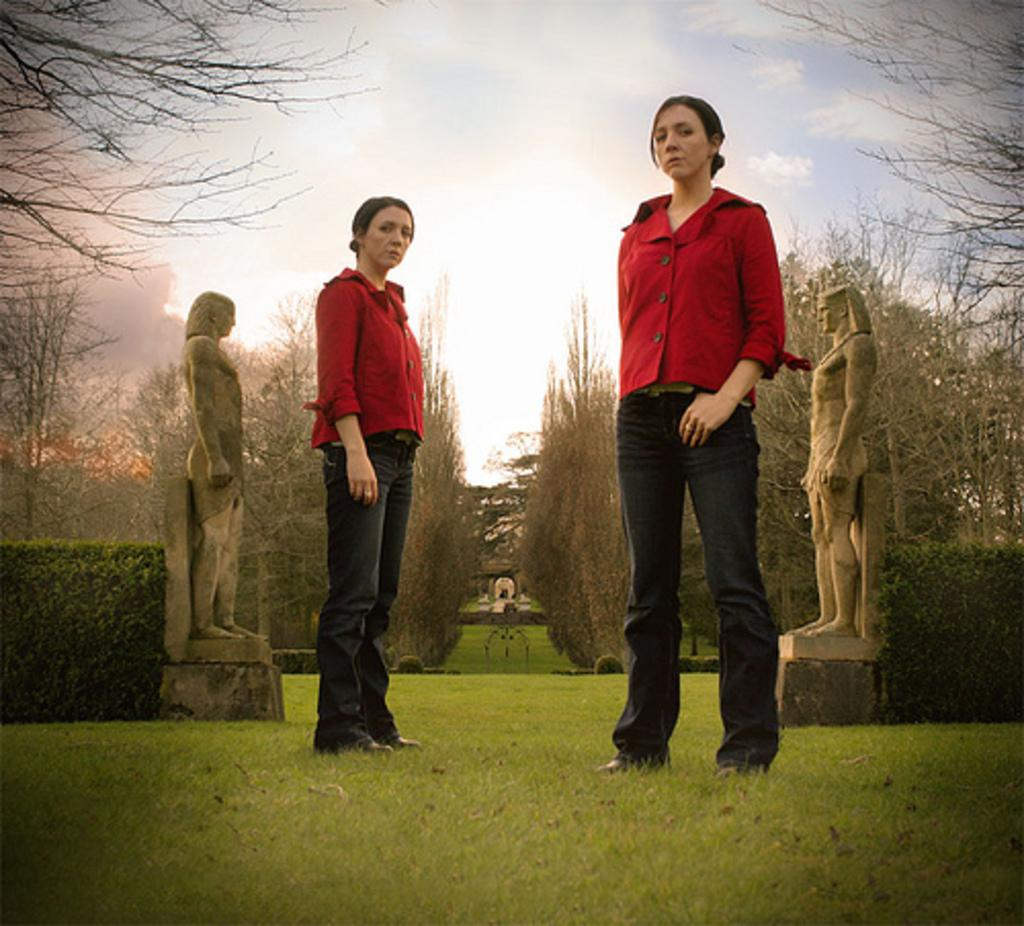What are the main subjects in the foreground of the image? There are persons standing on the ground in the foreground of the image. What can be seen in the background of the image? There are statues and trees in the background of the image. What is visible above the statues and trees? The sky is visible in the background of the image. What type of mist can be seen surrounding the persons in the image? There is no mist present in the image; the persons are standing on the ground with clear visibility. 